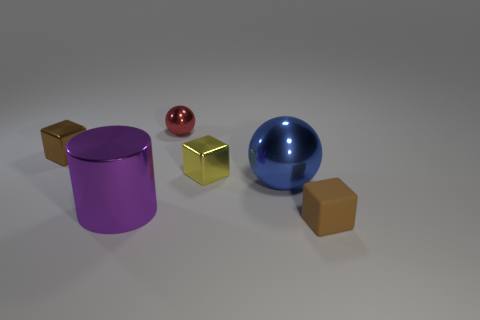Add 2 brown metal cylinders. How many objects exist? 8 Subtract all cylinders. How many objects are left? 5 Subtract all tiny metallic cubes. Subtract all yellow things. How many objects are left? 3 Add 6 tiny brown shiny objects. How many tiny brown shiny objects are left? 7 Add 6 big metallic spheres. How many big metallic spheres exist? 7 Subtract 0 gray cylinders. How many objects are left? 6 